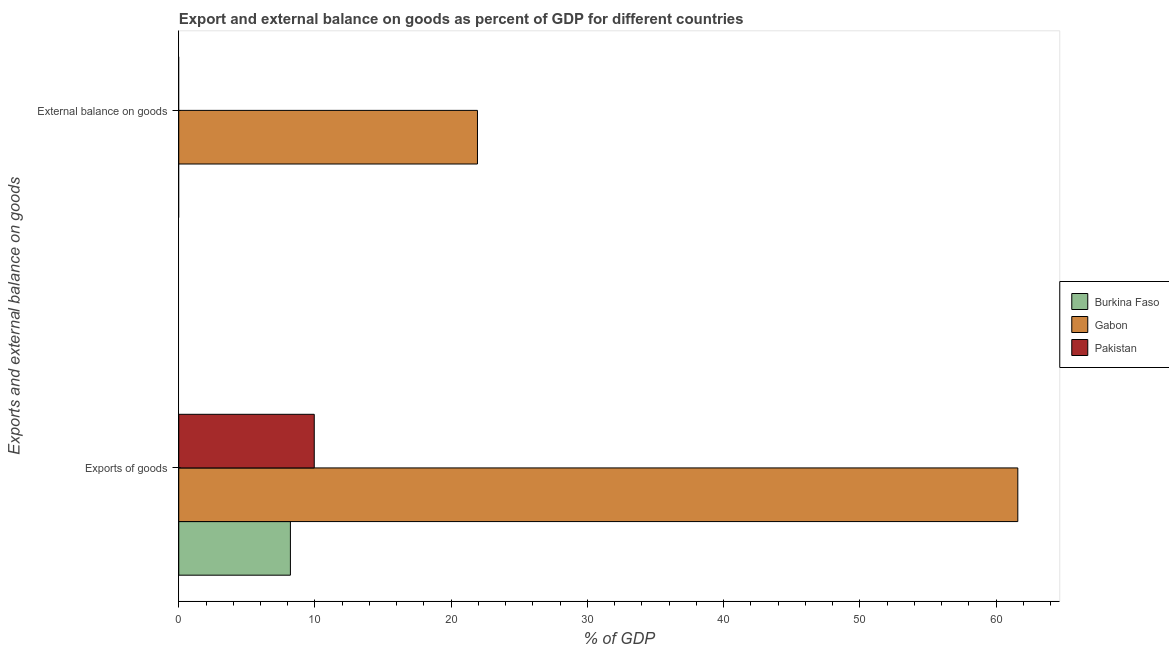How many bars are there on the 2nd tick from the bottom?
Provide a short and direct response. 1. What is the label of the 2nd group of bars from the top?
Your answer should be very brief. Exports of goods. What is the external balance on goods as percentage of gdp in Gabon?
Ensure brevity in your answer.  21.93. Across all countries, what is the maximum export of goods as percentage of gdp?
Ensure brevity in your answer.  61.59. Across all countries, what is the minimum export of goods as percentage of gdp?
Your response must be concise. 8.2. In which country was the export of goods as percentage of gdp maximum?
Provide a succinct answer. Gabon. What is the total export of goods as percentage of gdp in the graph?
Offer a terse response. 79.74. What is the difference between the export of goods as percentage of gdp in Burkina Faso and that in Pakistan?
Offer a very short reply. -1.75. What is the difference between the external balance on goods as percentage of gdp in Gabon and the export of goods as percentage of gdp in Pakistan?
Give a very brief answer. 11.98. What is the average external balance on goods as percentage of gdp per country?
Ensure brevity in your answer.  7.31. What is the difference between the external balance on goods as percentage of gdp and export of goods as percentage of gdp in Gabon?
Give a very brief answer. -39.67. In how many countries, is the external balance on goods as percentage of gdp greater than 48 %?
Provide a succinct answer. 0. What is the ratio of the export of goods as percentage of gdp in Burkina Faso to that in Pakistan?
Your response must be concise. 0.82. Is the export of goods as percentage of gdp in Gabon less than that in Pakistan?
Provide a succinct answer. No. Are all the bars in the graph horizontal?
Your answer should be very brief. Yes. How many countries are there in the graph?
Your answer should be very brief. 3. Does the graph contain any zero values?
Your answer should be very brief. Yes. What is the title of the graph?
Your answer should be very brief. Export and external balance on goods as percent of GDP for different countries. Does "Liechtenstein" appear as one of the legend labels in the graph?
Offer a very short reply. No. What is the label or title of the X-axis?
Provide a succinct answer. % of GDP. What is the label or title of the Y-axis?
Offer a very short reply. Exports and external balance on goods. What is the % of GDP in Burkina Faso in Exports of goods?
Your answer should be compact. 8.2. What is the % of GDP of Gabon in Exports of goods?
Make the answer very short. 61.59. What is the % of GDP in Pakistan in Exports of goods?
Provide a succinct answer. 9.95. What is the % of GDP in Burkina Faso in External balance on goods?
Provide a succinct answer. 0. What is the % of GDP of Gabon in External balance on goods?
Your answer should be very brief. 21.93. Across all Exports and external balance on goods, what is the maximum % of GDP in Burkina Faso?
Your response must be concise. 8.2. Across all Exports and external balance on goods, what is the maximum % of GDP of Gabon?
Ensure brevity in your answer.  61.59. Across all Exports and external balance on goods, what is the maximum % of GDP of Pakistan?
Provide a short and direct response. 9.95. Across all Exports and external balance on goods, what is the minimum % of GDP in Gabon?
Make the answer very short. 21.93. Across all Exports and external balance on goods, what is the minimum % of GDP of Pakistan?
Give a very brief answer. 0. What is the total % of GDP of Burkina Faso in the graph?
Offer a terse response. 8.2. What is the total % of GDP of Gabon in the graph?
Your response must be concise. 83.52. What is the total % of GDP in Pakistan in the graph?
Your answer should be compact. 9.95. What is the difference between the % of GDP in Gabon in Exports of goods and that in External balance on goods?
Your answer should be compact. 39.67. What is the difference between the % of GDP of Burkina Faso in Exports of goods and the % of GDP of Gabon in External balance on goods?
Your answer should be very brief. -13.73. What is the average % of GDP in Burkina Faso per Exports and external balance on goods?
Ensure brevity in your answer.  4.1. What is the average % of GDP in Gabon per Exports and external balance on goods?
Offer a terse response. 41.76. What is the average % of GDP in Pakistan per Exports and external balance on goods?
Your answer should be very brief. 4.97. What is the difference between the % of GDP of Burkina Faso and % of GDP of Gabon in Exports of goods?
Offer a terse response. -53.4. What is the difference between the % of GDP of Burkina Faso and % of GDP of Pakistan in Exports of goods?
Ensure brevity in your answer.  -1.75. What is the difference between the % of GDP of Gabon and % of GDP of Pakistan in Exports of goods?
Your answer should be compact. 51.65. What is the ratio of the % of GDP of Gabon in Exports of goods to that in External balance on goods?
Provide a succinct answer. 2.81. What is the difference between the highest and the second highest % of GDP in Gabon?
Ensure brevity in your answer.  39.67. What is the difference between the highest and the lowest % of GDP of Burkina Faso?
Provide a succinct answer. 8.2. What is the difference between the highest and the lowest % of GDP of Gabon?
Provide a short and direct response. 39.67. What is the difference between the highest and the lowest % of GDP in Pakistan?
Your answer should be very brief. 9.95. 